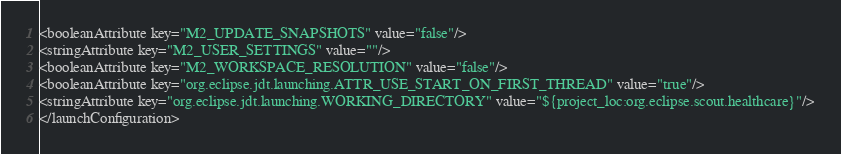<code> <loc_0><loc_0><loc_500><loc_500><_XML_><booleanAttribute key="M2_UPDATE_SNAPSHOTS" value="false"/>
<stringAttribute key="M2_USER_SETTINGS" value=""/>
<booleanAttribute key="M2_WORKSPACE_RESOLUTION" value="false"/>
<booleanAttribute key="org.eclipse.jdt.launching.ATTR_USE_START_ON_FIRST_THREAD" value="true"/>
<stringAttribute key="org.eclipse.jdt.launching.WORKING_DIRECTORY" value="${project_loc:org.eclipse.scout.healthcare}"/>
</launchConfiguration>
</code> 